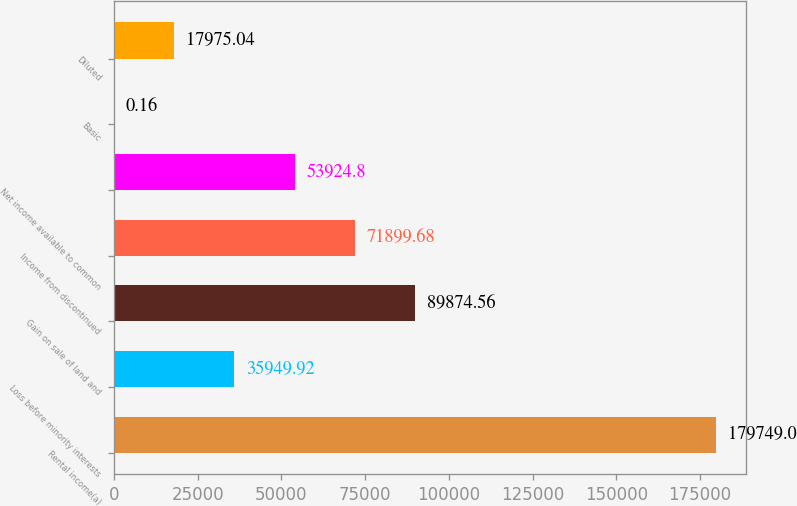Convert chart. <chart><loc_0><loc_0><loc_500><loc_500><bar_chart><fcel>Rental income(a)<fcel>Loss before minority interests<fcel>Gain on sale of land and<fcel>Income from discontinued<fcel>Net income available to common<fcel>Basic<fcel>Diluted<nl><fcel>179749<fcel>35949.9<fcel>89874.6<fcel>71899.7<fcel>53924.8<fcel>0.16<fcel>17975<nl></chart> 